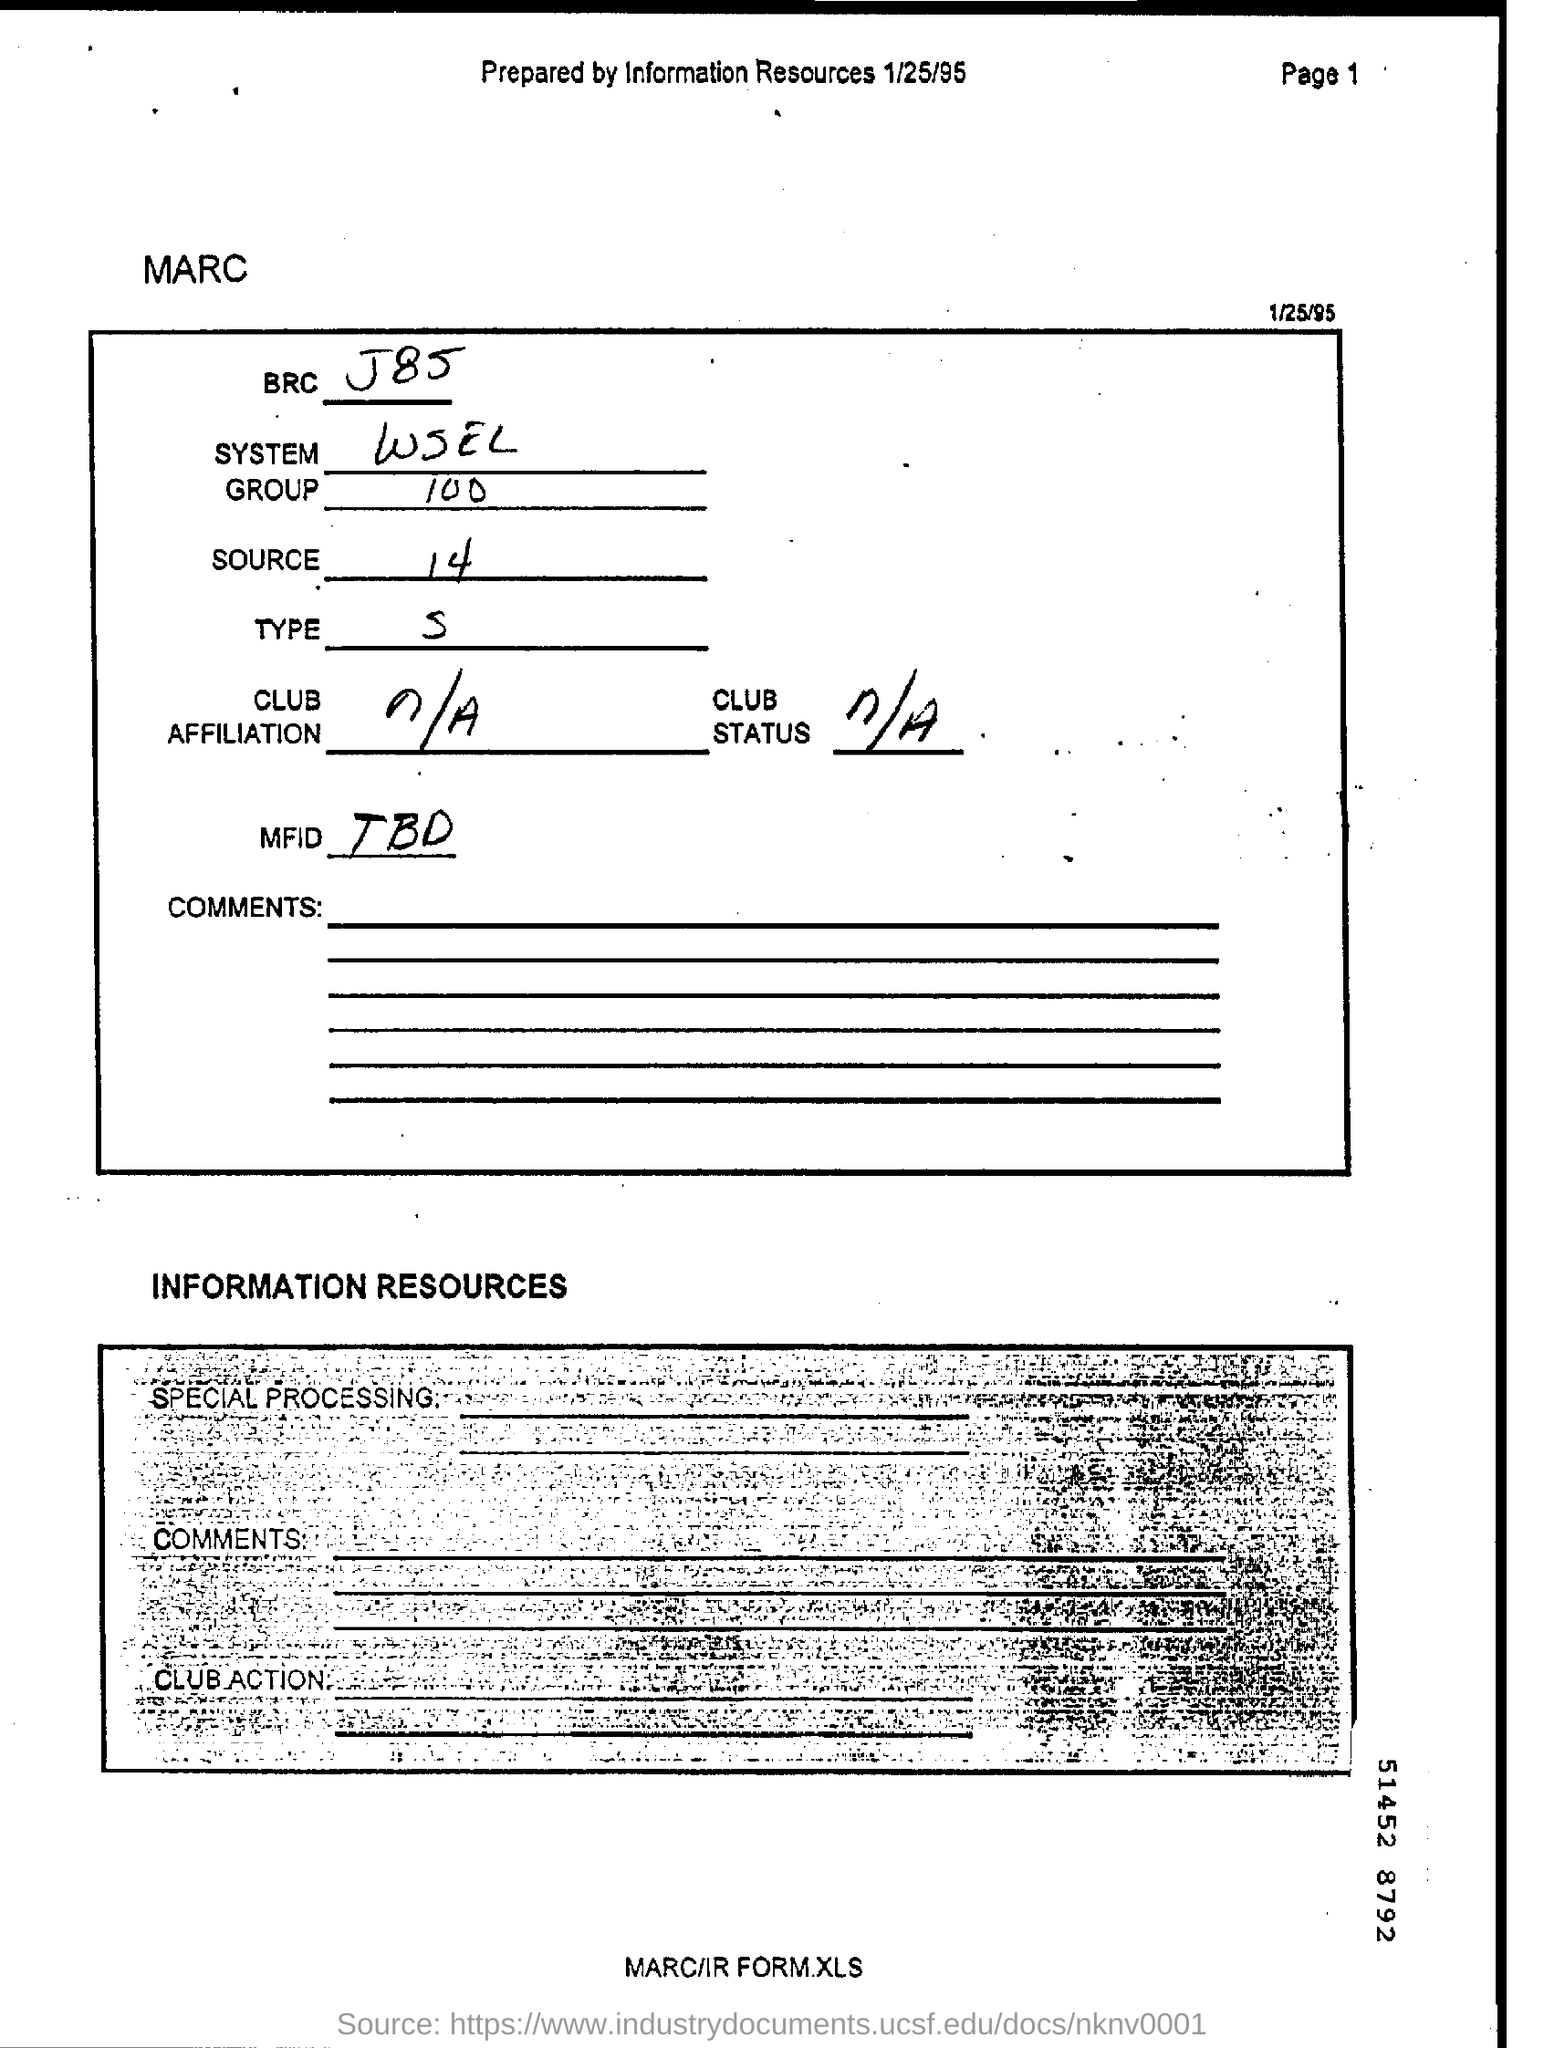What is the System?
Your answer should be very brief. WSEL. What is the Group?
Offer a terse response. 100. What is the date on the document?
Offer a very short reply. 1/25/95. 